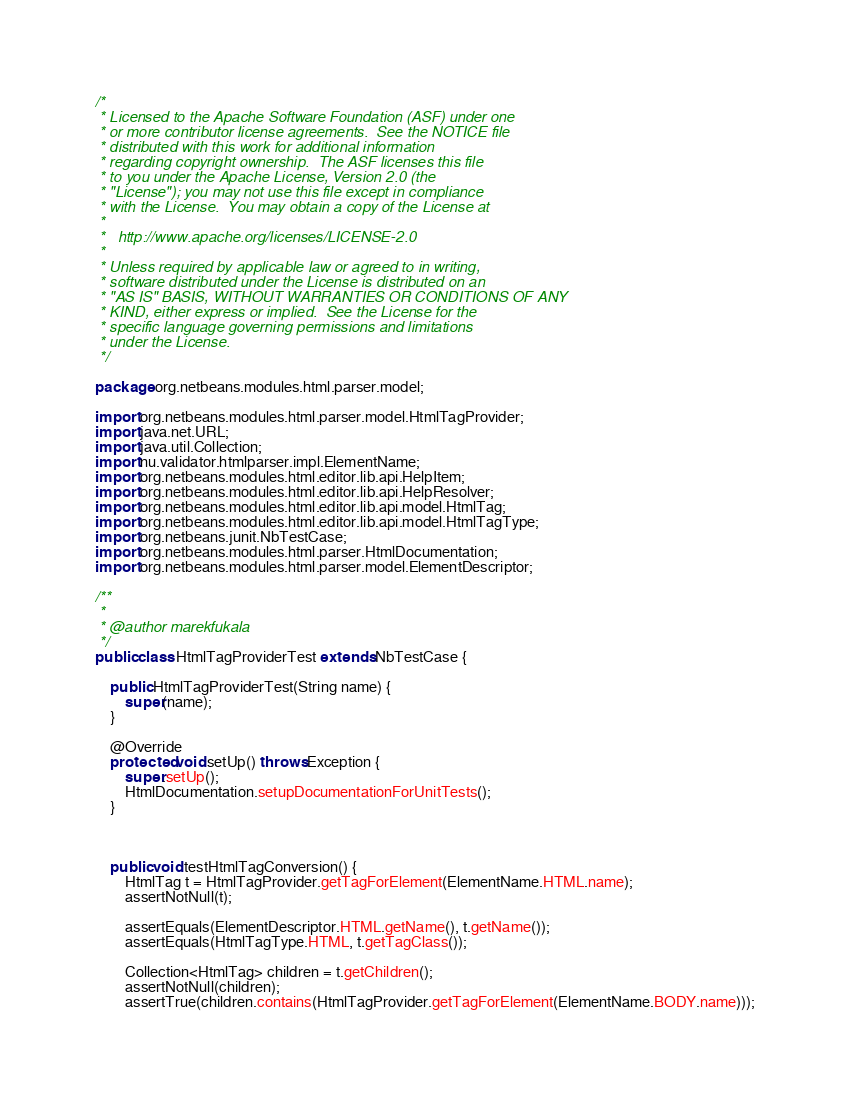<code> <loc_0><loc_0><loc_500><loc_500><_Java_>/*
 * Licensed to the Apache Software Foundation (ASF) under one
 * or more contributor license agreements.  See the NOTICE file
 * distributed with this work for additional information
 * regarding copyright ownership.  The ASF licenses this file
 * to you under the Apache License, Version 2.0 (the
 * "License"); you may not use this file except in compliance
 * with the License.  You may obtain a copy of the License at
 *
 *   http://www.apache.org/licenses/LICENSE-2.0
 *
 * Unless required by applicable law or agreed to in writing,
 * software distributed under the License is distributed on an
 * "AS IS" BASIS, WITHOUT WARRANTIES OR CONDITIONS OF ANY
 * KIND, either express or implied.  See the License for the
 * specific language governing permissions and limitations
 * under the License.
 */

package org.netbeans.modules.html.parser.model;

import org.netbeans.modules.html.parser.model.HtmlTagProvider;
import java.net.URL;
import java.util.Collection;
import nu.validator.htmlparser.impl.ElementName;
import org.netbeans.modules.html.editor.lib.api.HelpItem;
import org.netbeans.modules.html.editor.lib.api.HelpResolver;
import org.netbeans.modules.html.editor.lib.api.model.HtmlTag;
import org.netbeans.modules.html.editor.lib.api.model.HtmlTagType;
import org.netbeans.junit.NbTestCase;
import org.netbeans.modules.html.parser.HtmlDocumentation;
import org.netbeans.modules.html.parser.model.ElementDescriptor;

/**
 *
 * @author marekfukala
 */
public class HtmlTagProviderTest extends NbTestCase {

    public HtmlTagProviderTest(String name) {
        super(name);
    }

    @Override
    protected void setUp() throws Exception {
        super.setUp();
        HtmlDocumentation.setupDocumentationForUnitTests();
    }



    public void testHtmlTagConversion() {
        HtmlTag t = HtmlTagProvider.getTagForElement(ElementName.HTML.name);
        assertNotNull(t);

        assertEquals(ElementDescriptor.HTML.getName(), t.getName());
        assertEquals(HtmlTagType.HTML, t.getTagClass());

        Collection<HtmlTag> children = t.getChildren();
        assertNotNull(children);
        assertTrue(children.contains(HtmlTagProvider.getTagForElement(ElementName.BODY.name)));</code> 